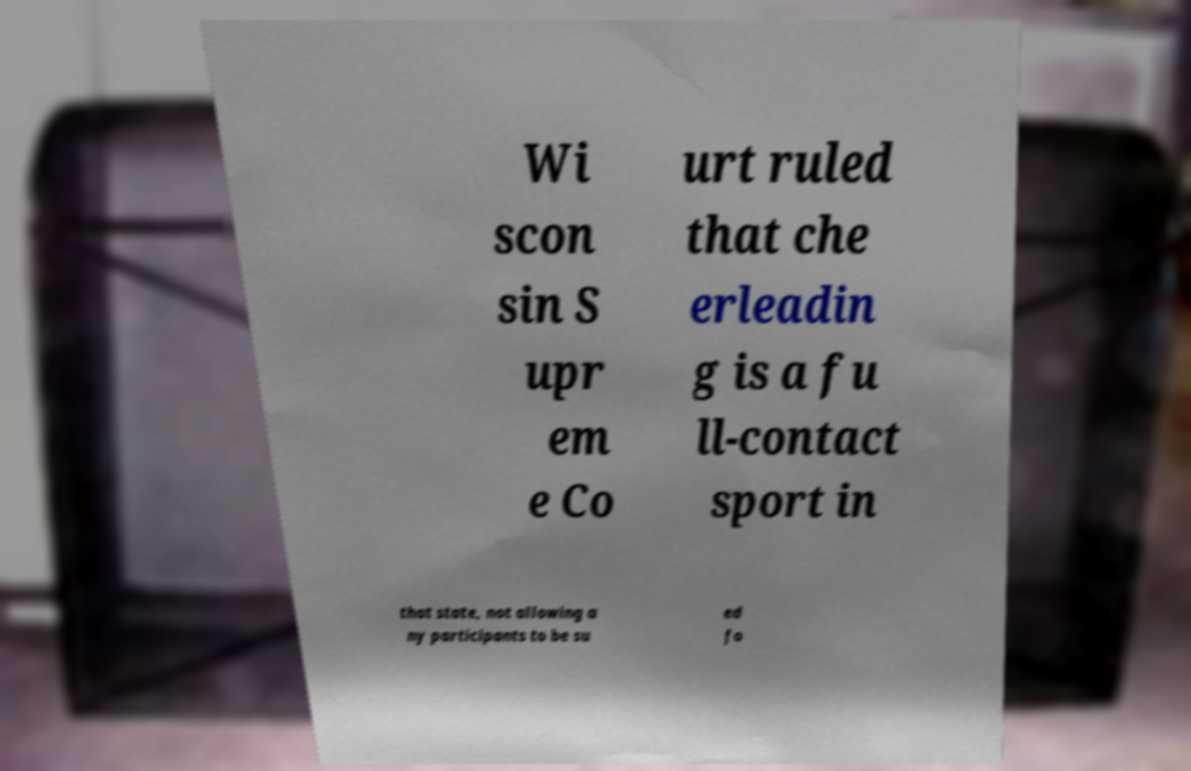Please identify and transcribe the text found in this image. Wi scon sin S upr em e Co urt ruled that che erleadin g is a fu ll-contact sport in that state, not allowing a ny participants to be su ed fo 